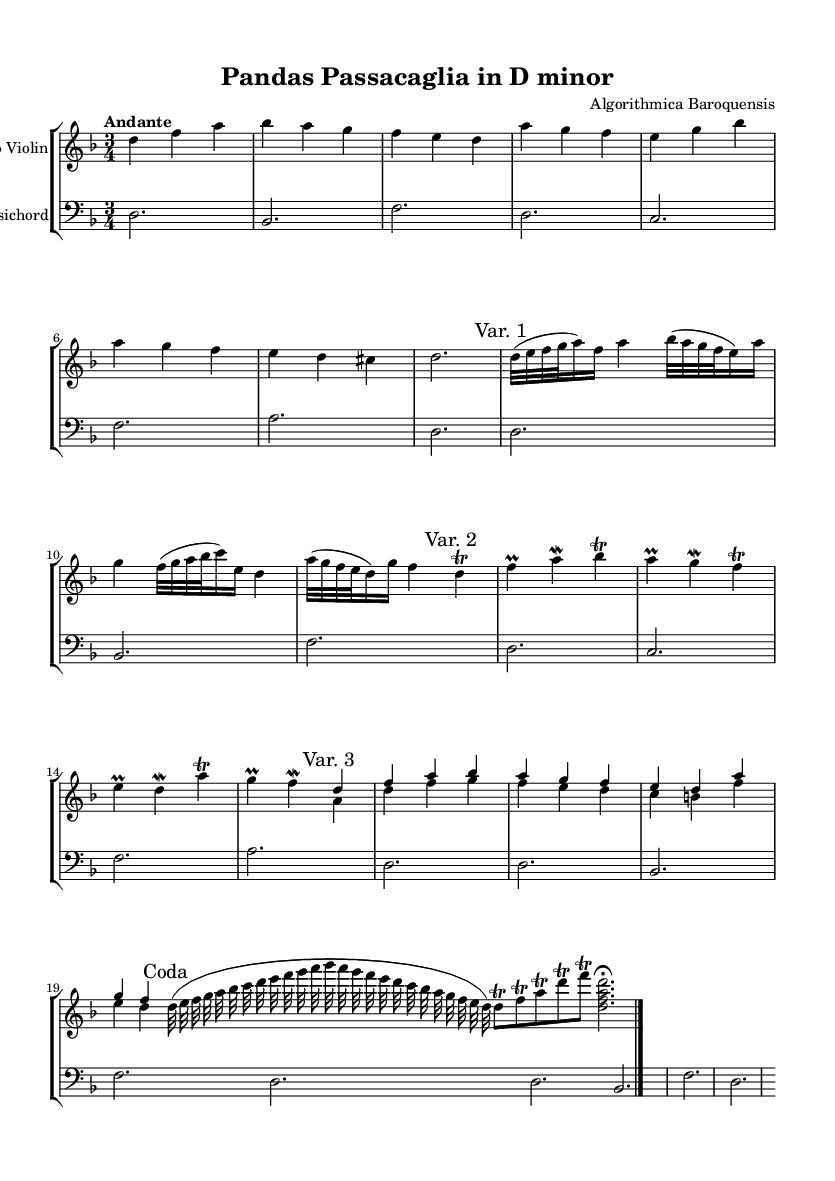What is the key signature of this music? The key signature is indicated by the presence of one flat (B) in the music. It is located at the beginning of the staff.
Answer: D minor What is the time signature of this music? The time signature is shown at the beginning of the sheet music and indicated as "3/4". This means there are three beats in a measure and the quarter note gets one beat.
Answer: 3/4 What is the tempo marking of the piece? The tempo marking is provided at the beginning of the score and states "Andante", which indicates a moderate walking pace.
Answer: Andante How many variations are there in the piece? By observing the labels for the different sections within the violin part, it's clear that there are three variations and a coda. The marks indicating variations confirm this segmentation.
Answer: Three In what context do we find the term "cadenza" within this piece? The term "cadenza" is marked in the score, indicating an ornamental solo passage for the violin, commonly found in Baroque music, particularly in the coda section.
Answer: Coda What type of musical embellishment is used in Variation 2? The notation in Variation 2 represents trill notations and ornaments, typical in Baroque music to add complexity and expressiveness to the melody.
Answer: Trills Which instrument accompanies the solo violin? The accompanying staff is labeled "Harpsichord," which is the instrument supporting the violin and is a staple in Baroque compositions.
Answer: Harpsichord 